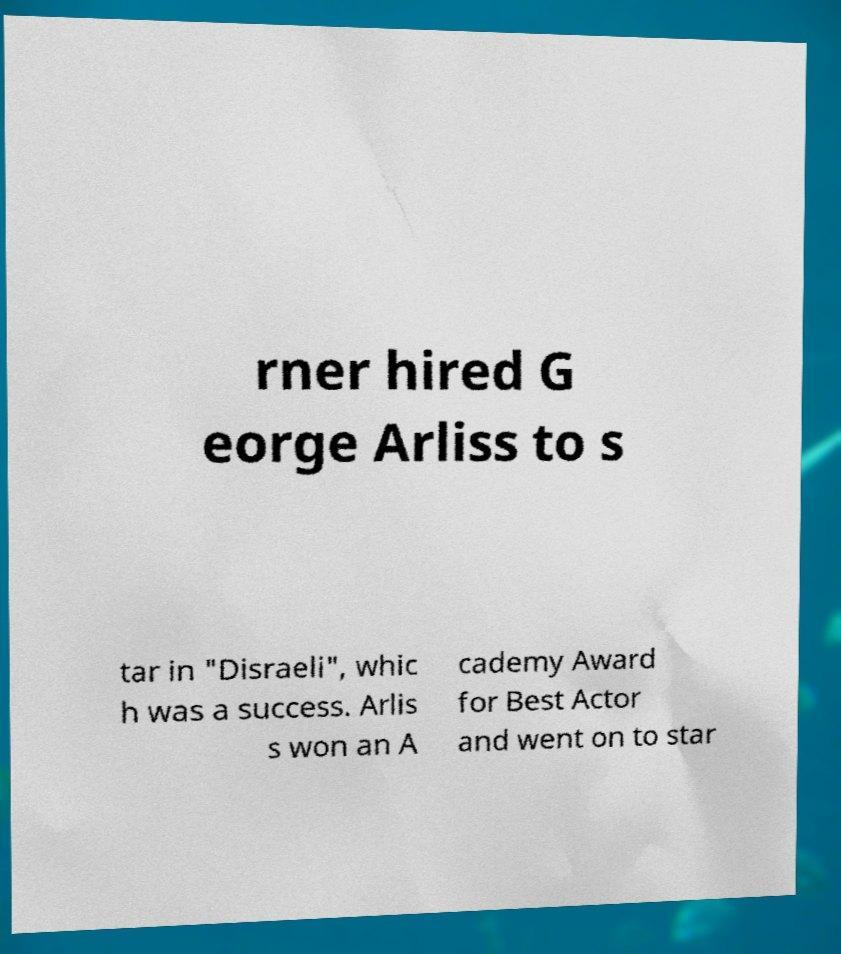I need the written content from this picture converted into text. Can you do that? rner hired G eorge Arliss to s tar in "Disraeli", whic h was a success. Arlis s won an A cademy Award for Best Actor and went on to star 